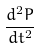<formula> <loc_0><loc_0><loc_500><loc_500>\frac { d ^ { 2 } P } { d t ^ { 2 } }</formula> 